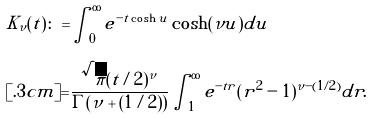Convert formula to latex. <formula><loc_0><loc_0><loc_500><loc_500>K _ { \nu } ( t ) \colon = & \int _ { 0 } ^ { \infty } e ^ { - t \cosh u } \cosh ( \nu u ) d u \\ [ . 3 c m ] = & \frac { \sqrt { \pi } ( t / 2 ) ^ { \nu } } { \Gamma ( \nu + ( 1 / 2 ) ) } \int _ { 1 } ^ { \infty } e ^ { - t r } ( r ^ { 2 } - 1 ) ^ { \nu - ( 1 / 2 ) } d r .</formula> 